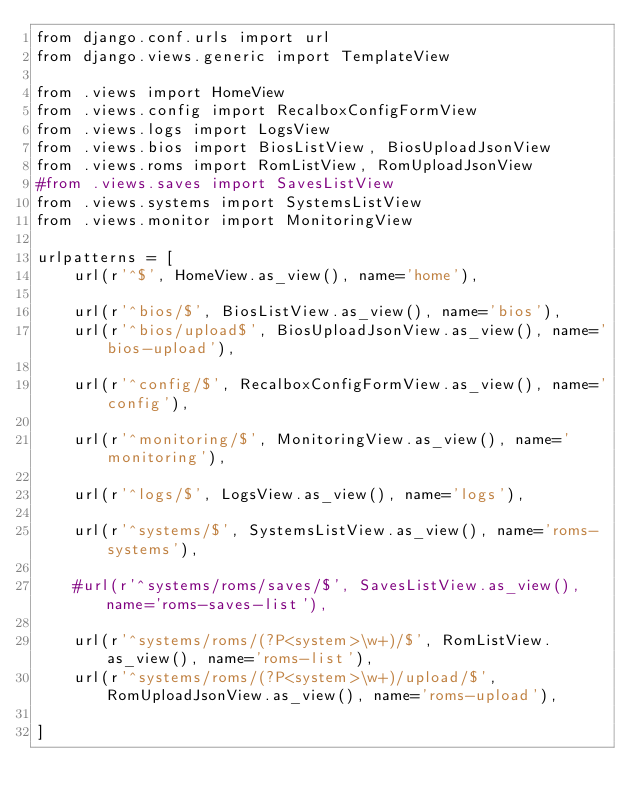Convert code to text. <code><loc_0><loc_0><loc_500><loc_500><_Python_>from django.conf.urls import url
from django.views.generic import TemplateView

from .views import HomeView
from .views.config import RecalboxConfigFormView
from .views.logs import LogsView
from .views.bios import BiosListView, BiosUploadJsonView
from .views.roms import RomListView, RomUploadJsonView
#from .views.saves import SavesListView
from .views.systems import SystemsListView
from .views.monitor import MonitoringView

urlpatterns = [
    url(r'^$', HomeView.as_view(), name='home'),
    
    url(r'^bios/$', BiosListView.as_view(), name='bios'),
    url(r'^bios/upload$', BiosUploadJsonView.as_view(), name='bios-upload'),
    
    url(r'^config/$', RecalboxConfigFormView.as_view(), name='config'),
    
    url(r'^monitoring/$', MonitoringView.as_view(), name='monitoring'),
    
    url(r'^logs/$', LogsView.as_view(), name='logs'),
    
    url(r'^systems/$', SystemsListView.as_view(), name='roms-systems'),
    
    #url(r'^systems/roms/saves/$', SavesListView.as_view(), name='roms-saves-list'),
    
    url(r'^systems/roms/(?P<system>\w+)/$', RomListView.as_view(), name='roms-list'),
    url(r'^systems/roms/(?P<system>\w+)/upload/$', RomUploadJsonView.as_view(), name='roms-upload'),

]</code> 